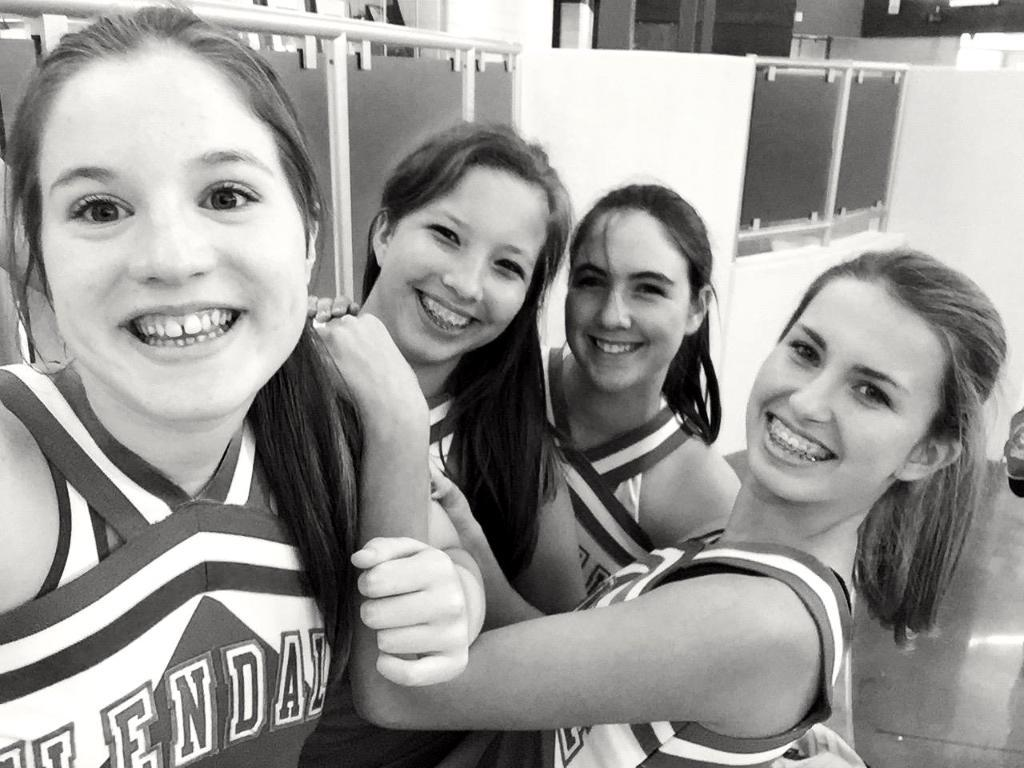What is the color scheme of the image? The image is black and white. Who is present in the image? There are girls in the image. What is the facial expression of the girls? The girls are smiling. What can be seen in the background of the image? There are walls, windows, and glass doors in the background of the image. Are there any other objects visible in the background? Yes, there are other objects in the background of the image. How does the image contribute to reducing pollution in the coast? The image does not address pollution or the coast; it is a black and white image of girls smiling with a background of walls, windows, and glass doors. 